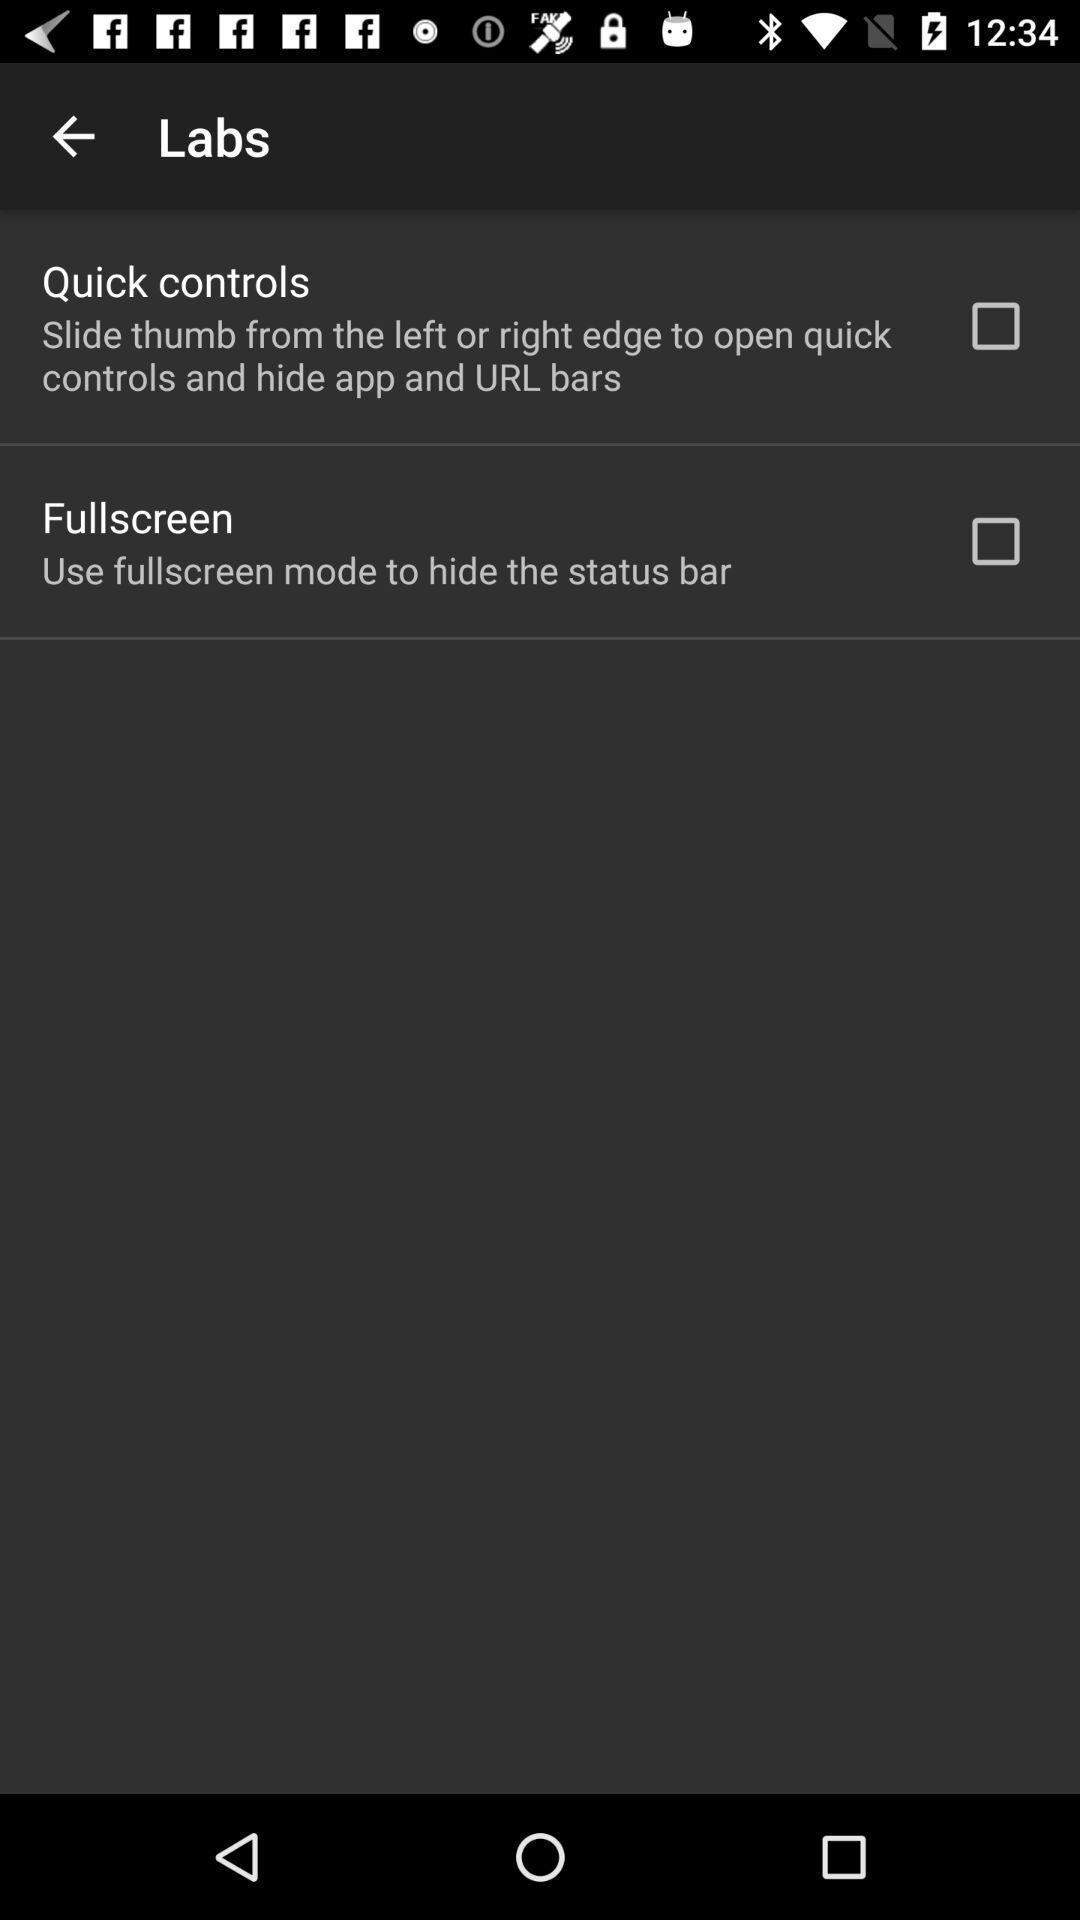Tell me about the visual elements in this screen capture. Screen shows labs details. 